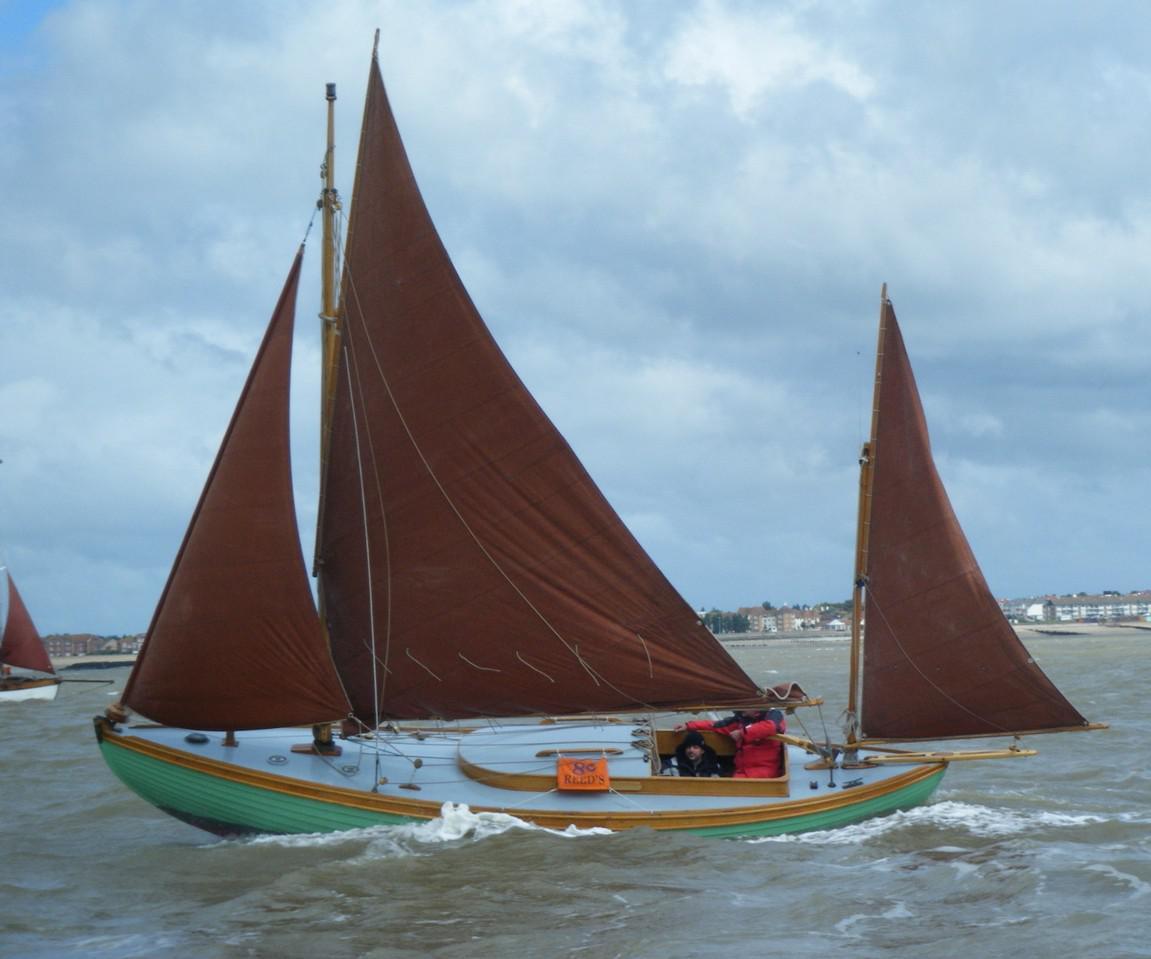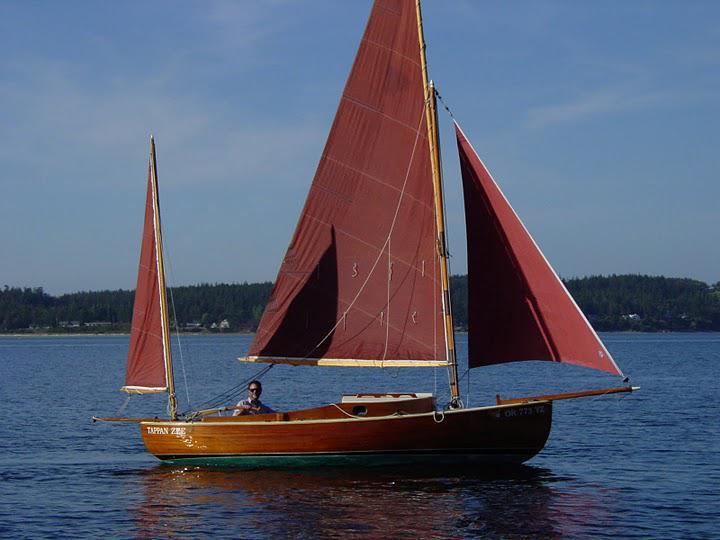The first image is the image on the left, the second image is the image on the right. Given the left and right images, does the statement "In one of the images there is a green and brown boat with brown sails" hold true? Answer yes or no. Yes. 